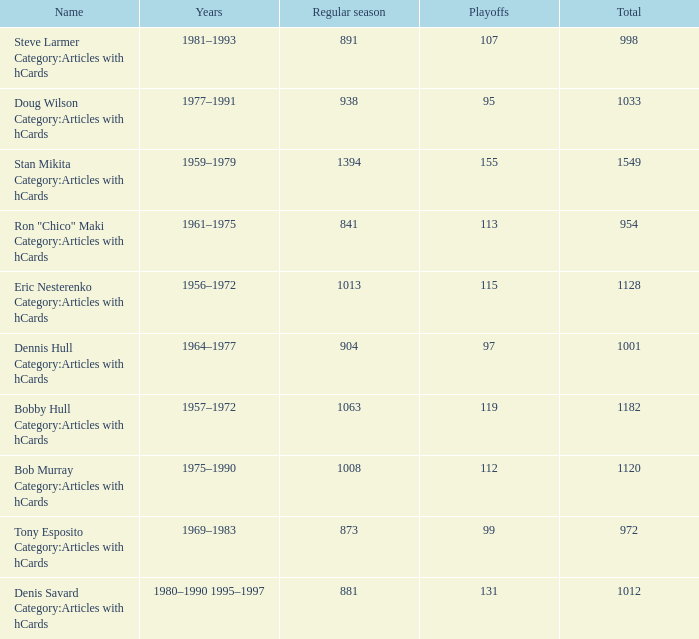How may times is regular season 1063 and playoffs more than 119? 0.0. 